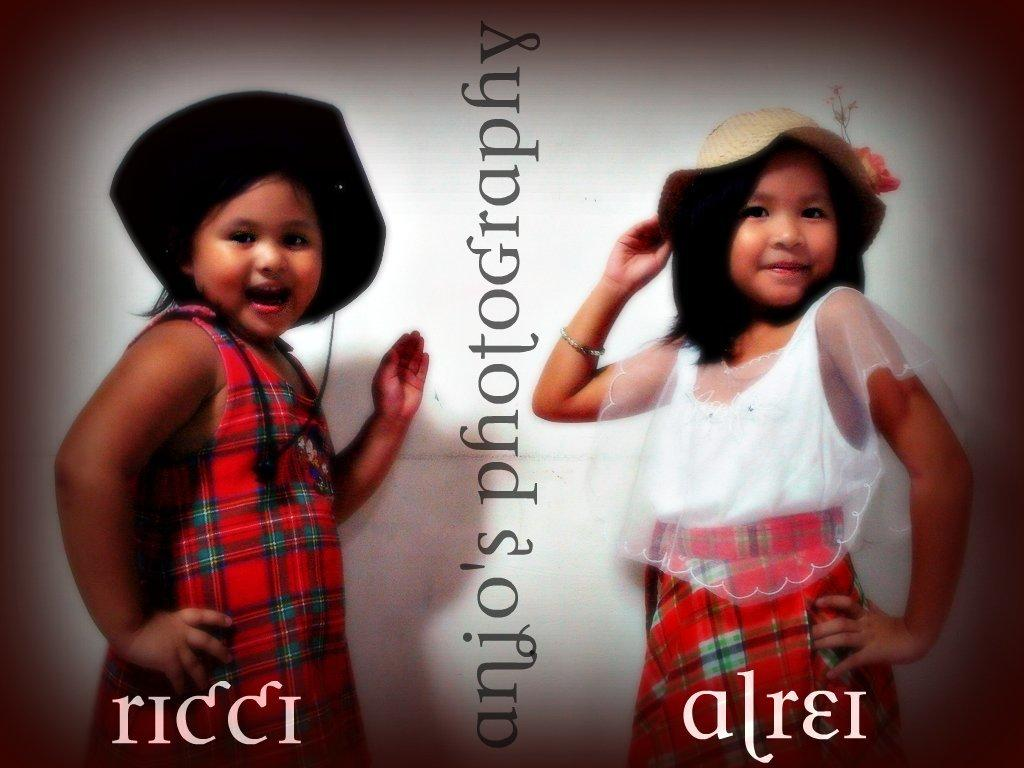How many people are in the image? There are two girls in the image. What are the girls doing in the image? The girls are facing each other. What are the girls wearing on their heads? The girls are wearing hats. What can be seen in the middle of the image? There is some text in the middle of the image. What color is the wall in the background? The wall in the background is white. What type of fuel is being used by the arch in the image? There is no arch or fuel present in the image. What fact can be determined about the girls' relationship based on the image? The image does not provide enough information to determine the girls' relationship. 